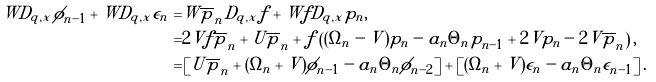Convert formula to latex. <formula><loc_0><loc_0><loc_500><loc_500>W D _ { q , x } \phi _ { n - 1 } + W D _ { q , x } \epsilon _ { n } = & W \overline { p } _ { n } D _ { q , x } f + W f D _ { q , x } p _ { n } , \\ = & 2 V f \overline { p } _ { n } + U \overline { p } _ { n } + f \left ( ( \Omega _ { n } - V ) p _ { n } - a _ { n } \Theta _ { n } p _ { n - 1 } + 2 V p _ { n } - 2 V \overline { p } _ { n } \right ) , \\ = & \left [ U \overline { p } _ { n } + ( \Omega _ { n } + V ) \phi _ { n - 1 } - a _ { n } \Theta _ { n } \phi _ { n - 2 } \right ] + \left [ ( \Omega _ { n } + V ) \epsilon _ { n } - a _ { n } \Theta _ { n } \epsilon _ { n - 1 } \right ] .</formula> 